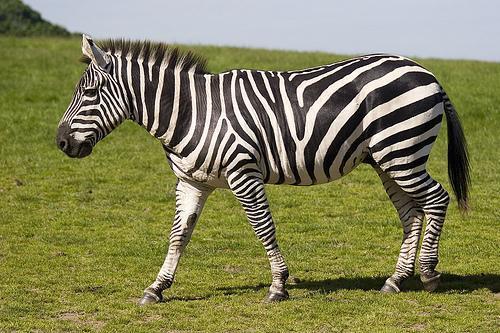How many zebras are there?
Give a very brief answer. 1. 